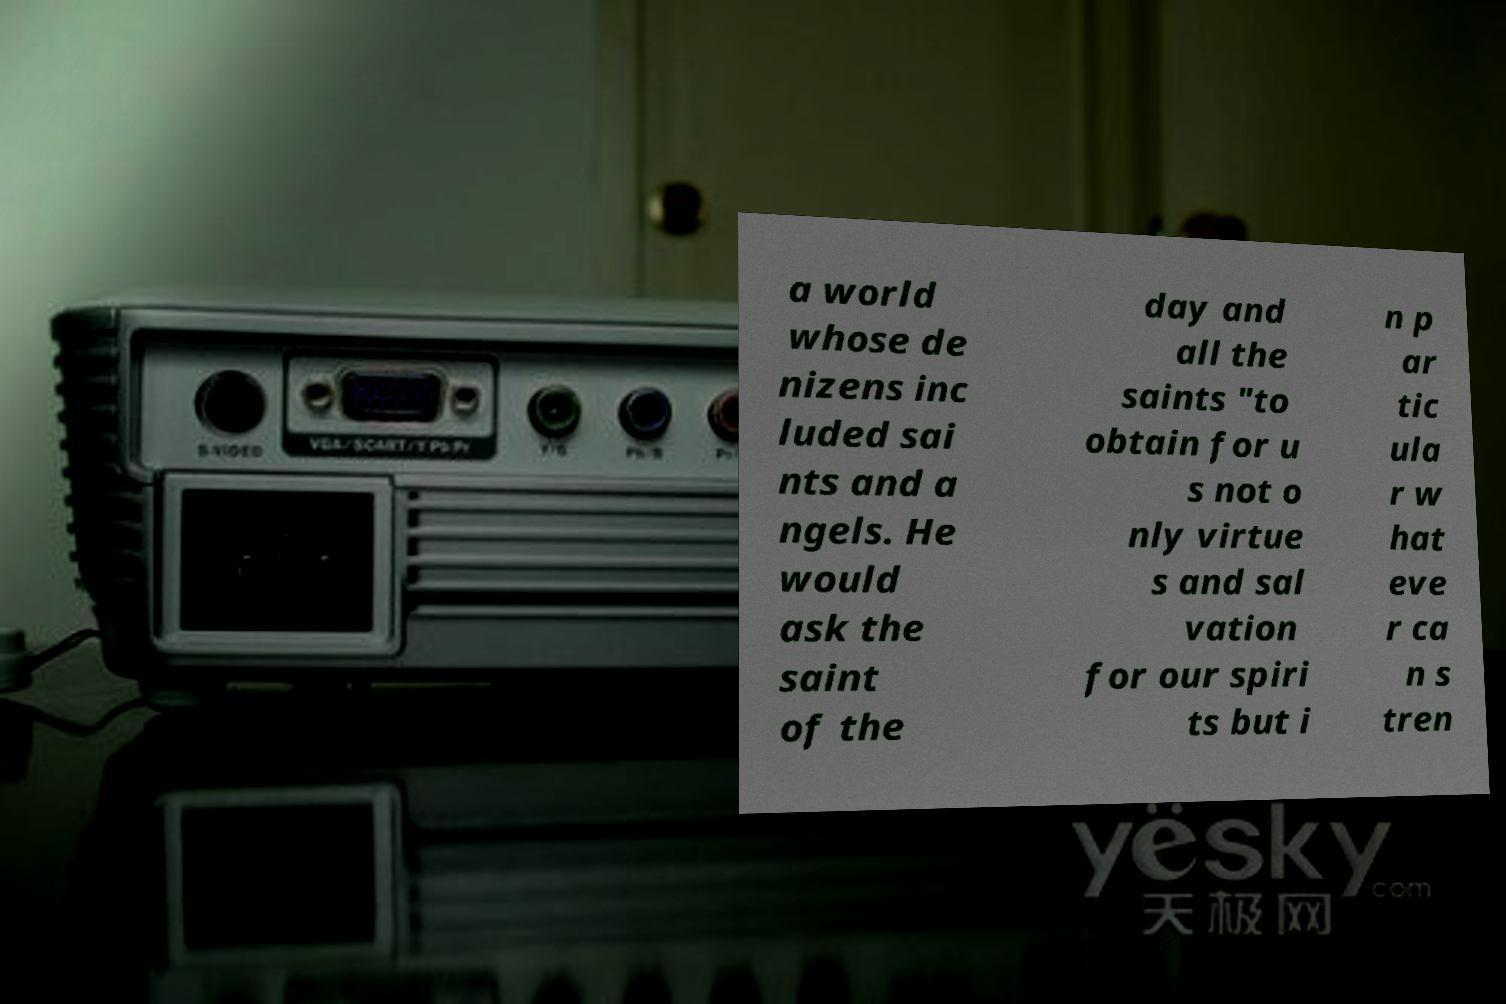Can you accurately transcribe the text from the provided image for me? a world whose de nizens inc luded sai nts and a ngels. He would ask the saint of the day and all the saints "to obtain for u s not o nly virtue s and sal vation for our spiri ts but i n p ar tic ula r w hat eve r ca n s tren 